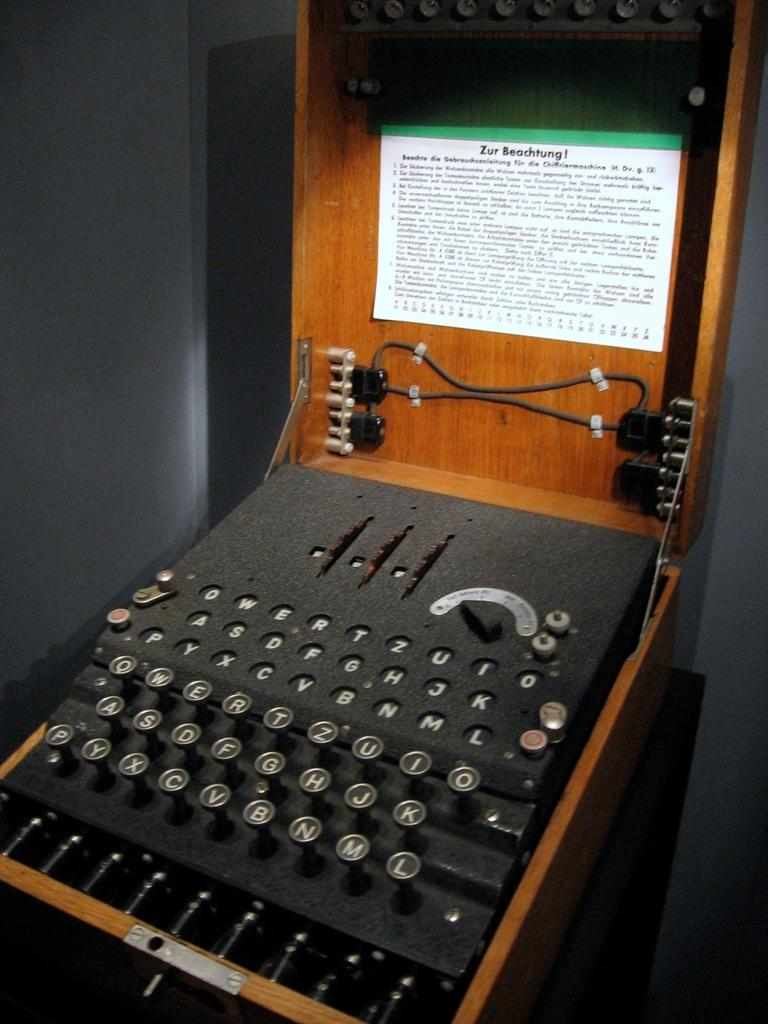<image>
Provide a brief description of the given image. A very old looking typewriter with an instruction manual that starts with the phrase Zur Beachtung. 